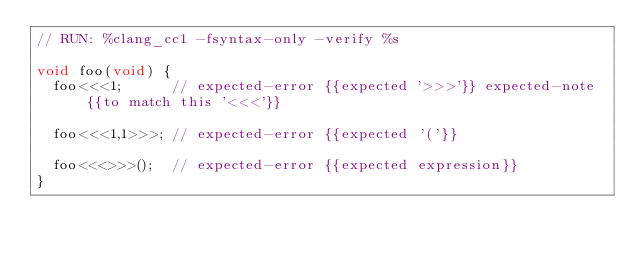<code> <loc_0><loc_0><loc_500><loc_500><_Cuda_>// RUN: %clang_cc1 -fsyntax-only -verify %s

void foo(void) {
  foo<<<1;      // expected-error {{expected '>>>'}} expected-note {{to match this '<<<'}}

  foo<<<1,1>>>; // expected-error {{expected '('}}

  foo<<<>>>();  // expected-error {{expected expression}}
}
</code> 